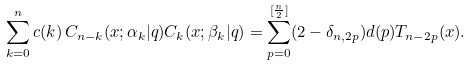<formula> <loc_0><loc_0><loc_500><loc_500>\sum _ { k = 0 } ^ { n } c ( k ) \, C _ { n - k } ( x ; \alpha _ { k } | q ) C _ { k } ( x ; \beta _ { k } | q ) = \sum _ { p = 0 } ^ { [ \frac { n } { 2 } ] } ( 2 - \delta _ { n , 2 p } ) d ( p ) T _ { n - 2 p } ( x ) .</formula> 